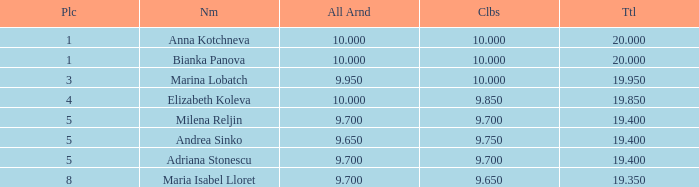How many places have bianka panova as the name, with clubs less than 10? 0.0. 